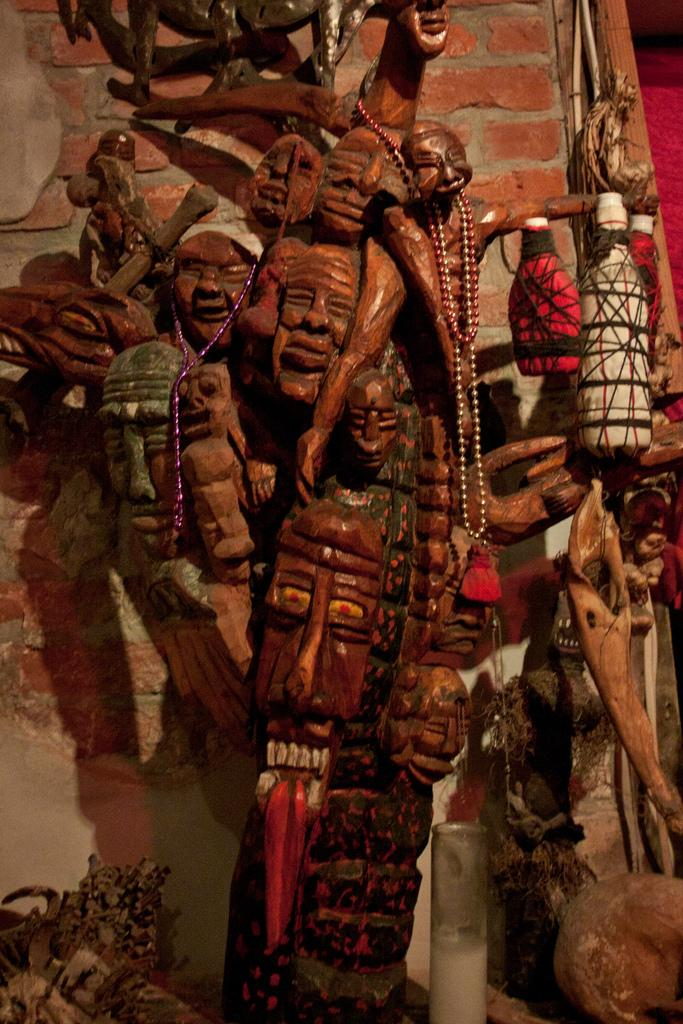What type of subject matter is present in the image? The image contains architecture. Can you describe any specific architectural features in the image? Unfortunately, the provided facts do not give enough detail to describe specific architectural features. What is visible in the background of the image? There is a wall visible in the background of the image. What type of club is being used by the slaves in the image? There is no mention of a club or slaves in the image; it contains architecture and a wall in the background. 